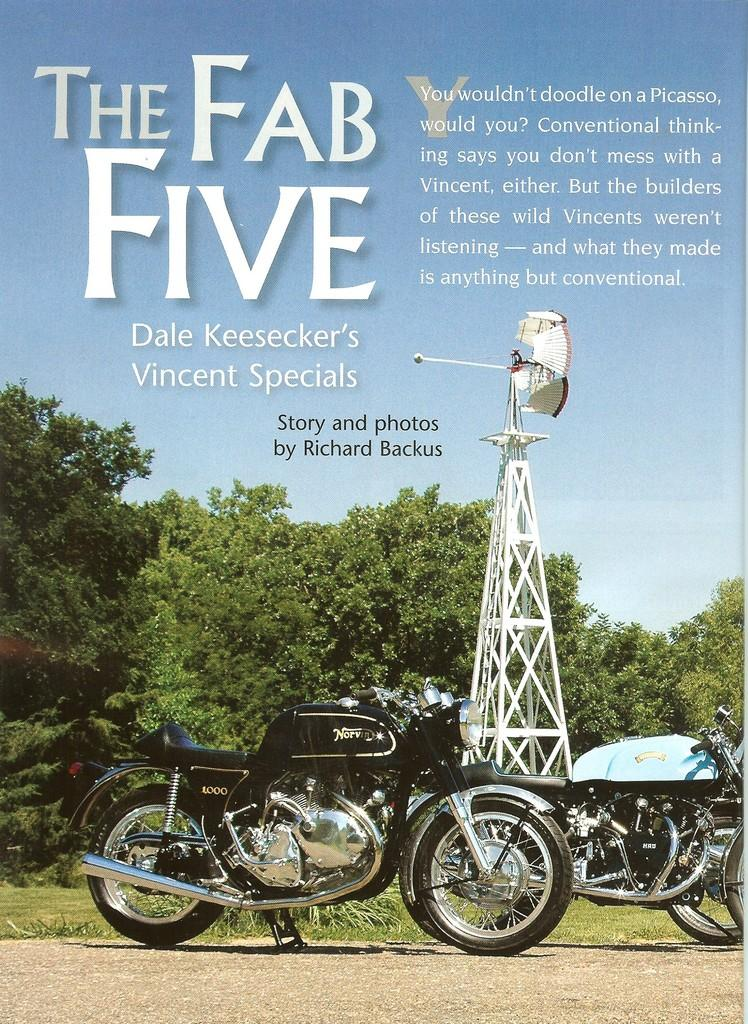How many motorbikes are in the image? There are two motorbikes in the image. Where are the motorbikes located? The motorbikes are parked on the road. What can be seen in the background of the image? There are trees, a white color tower, and the sky visible in the background of the image. Is there any text present in the image? Yes, there is text at the top of the image. Can you tell me how many ducks are sitting on the motorbikes in the image? There are no ducks present in the image; it only features two motorbikes parked on the road. What color is the crayon used to draw the tower in the background of the image? There is no crayon or drawing in the image; the tower is a real structure visible in the background. 